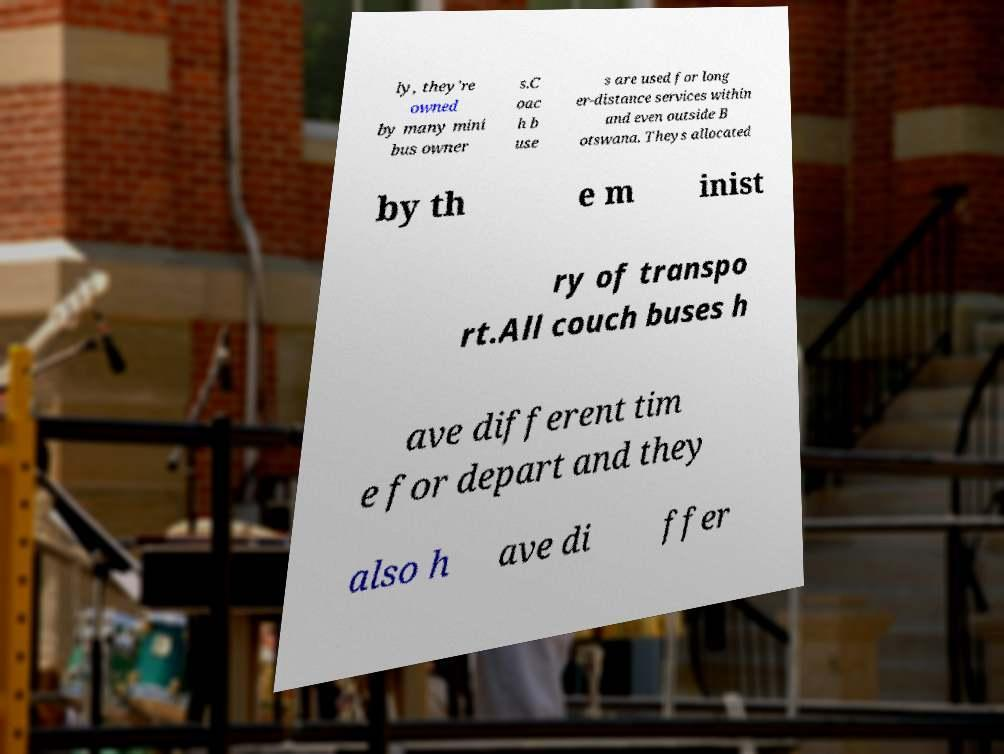Please read and relay the text visible in this image. What does it say? ly, they're owned by many mini bus owner s.C oac h b use s are used for long er-distance services within and even outside B otswana. Theys allocated by th e m inist ry of transpo rt.All couch buses h ave different tim e for depart and they also h ave di ffer 